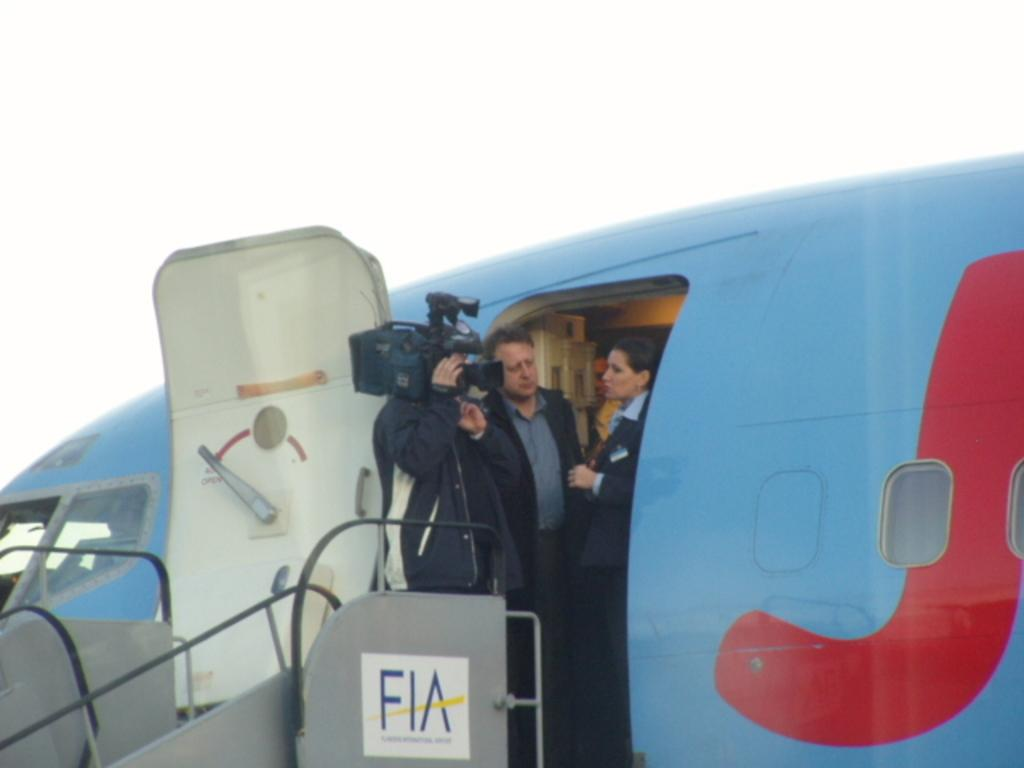<image>
Offer a succinct explanation of the picture presented. A woan getting off a Fia plane with a camera in her face 